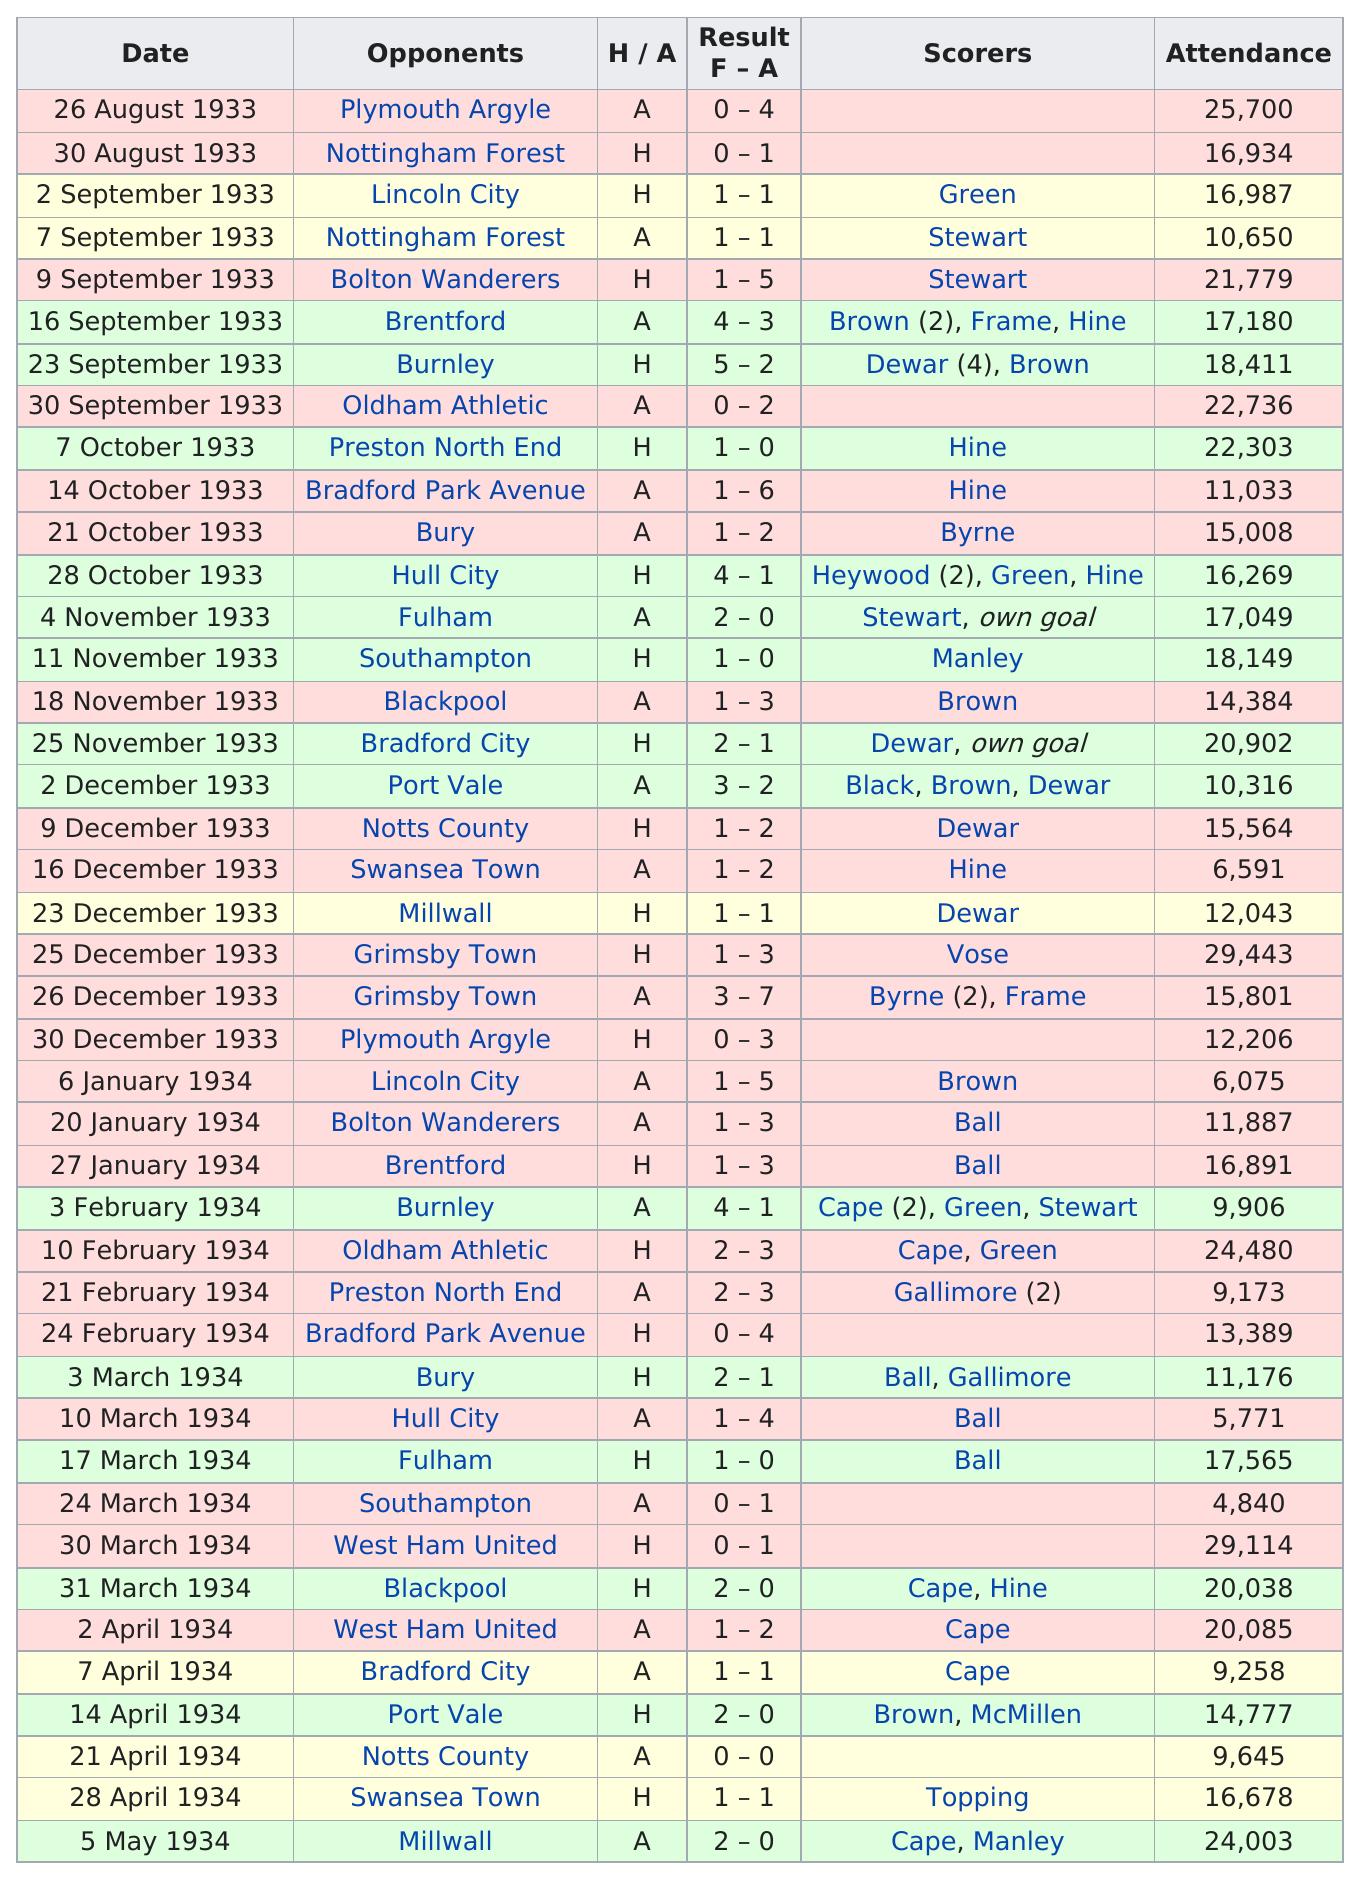Identify some key points in this picture. On October 7, a total of 22,303 people attended the game, and 22,736 people attended the previous game. On December 2, 1933, 10,316 people attended the game. On September 23, 1933, the scorer for the opposing team was Dewar (4) and Brown. The combined attendance for August 26 and August 30, 1933, was 42,634. The last game of the 1933-1934 season took place on May 5, 1934. 